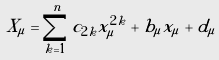Convert formula to latex. <formula><loc_0><loc_0><loc_500><loc_500>X _ { \mu } = \sum _ { k = 1 } ^ { n } c _ { 2 k } x _ { \mu } ^ { 2 k } + b _ { \mu } x _ { \mu } + d _ { \mu }</formula> 